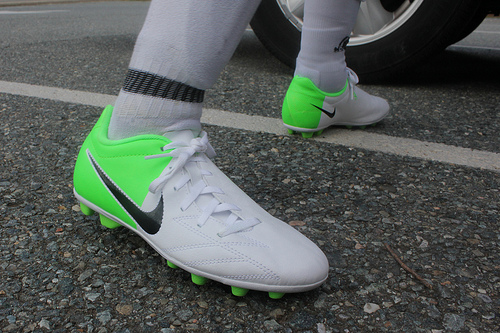<image>
Is the check mark on the sneaker? Yes. Looking at the image, I can see the check mark is positioned on top of the sneaker, with the sneaker providing support. 